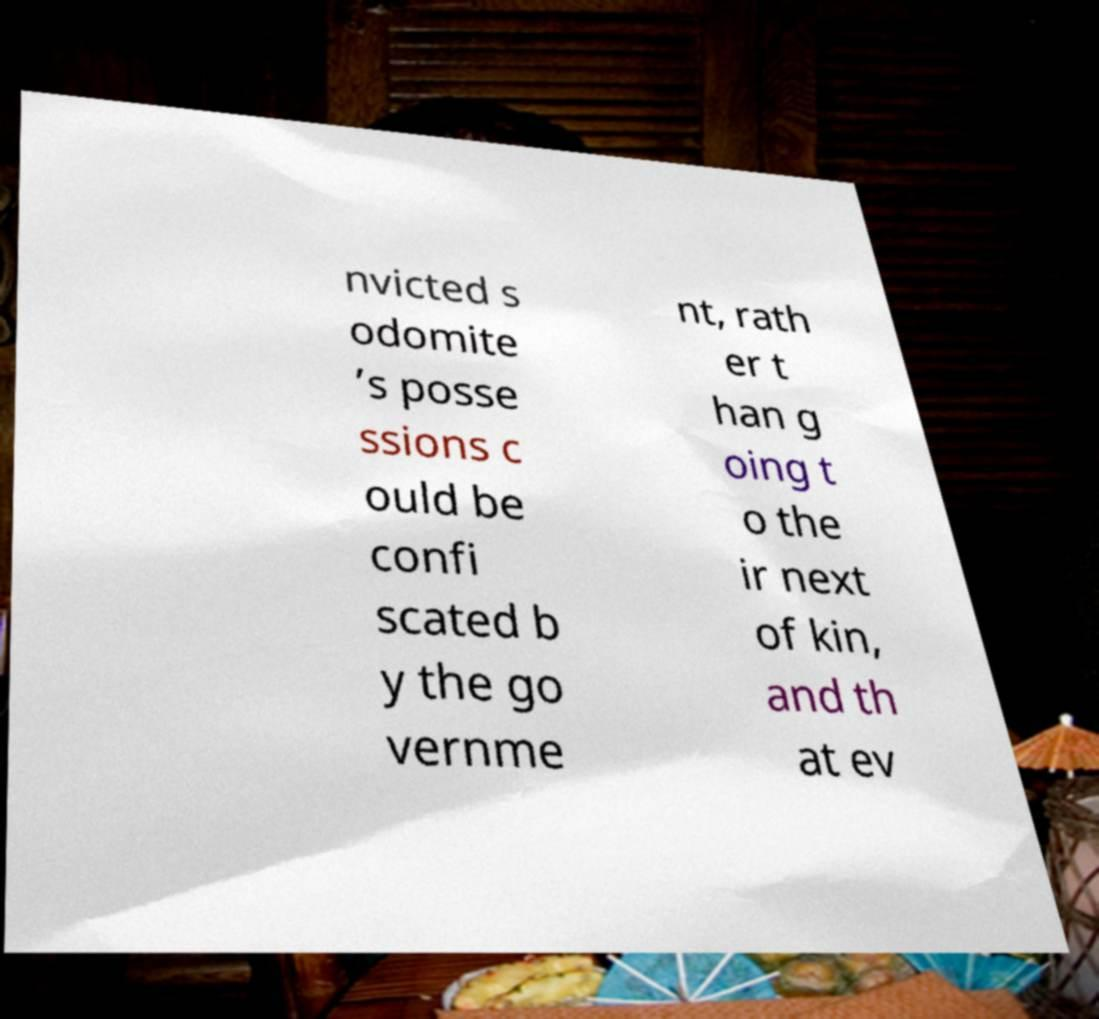Can you read and provide the text displayed in the image?This photo seems to have some interesting text. Can you extract and type it out for me? nvicted s odomite ’s posse ssions c ould be confi scated b y the go vernme nt, rath er t han g oing t o the ir next of kin, and th at ev 